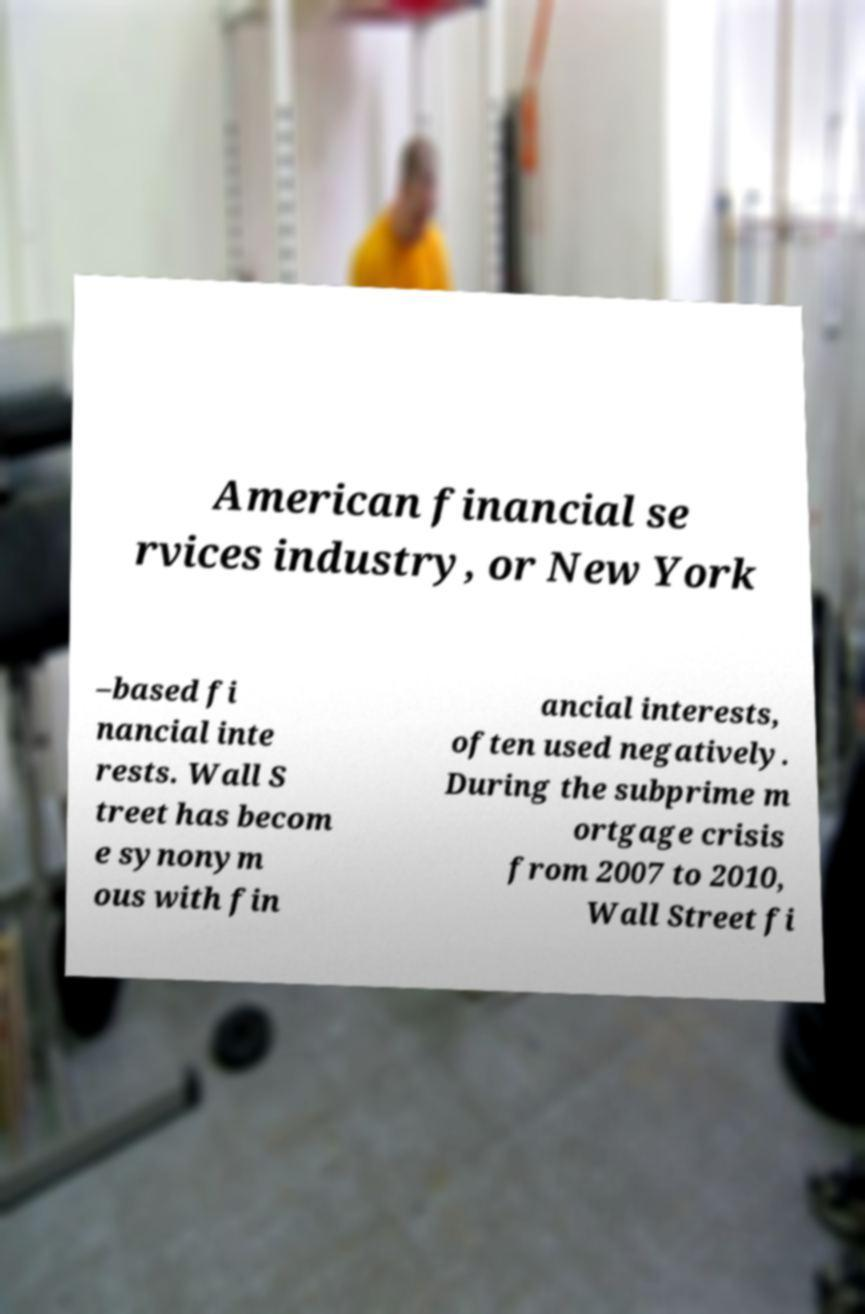Please identify and transcribe the text found in this image. American financial se rvices industry, or New York –based fi nancial inte rests. Wall S treet has becom e synonym ous with fin ancial interests, often used negatively. During the subprime m ortgage crisis from 2007 to 2010, Wall Street fi 